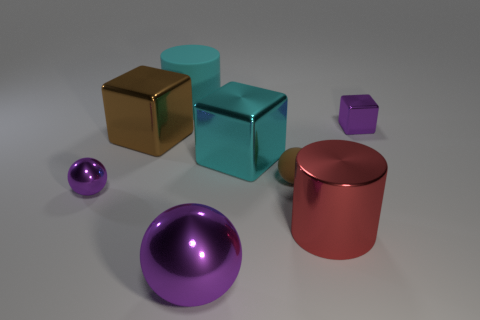Subtract all big spheres. How many spheres are left? 2 Subtract all blue cubes. How many purple spheres are left? 2 Add 2 large yellow matte things. How many objects exist? 10 Subtract 2 balls. How many balls are left? 1 Subtract all purple blocks. How many blocks are left? 2 Subtract all cubes. How many objects are left? 5 Subtract all cyan cylinders. Subtract all green cubes. How many cylinders are left? 1 Subtract all big green metal spheres. Subtract all large cubes. How many objects are left? 6 Add 4 tiny shiny objects. How many tiny shiny objects are left? 6 Add 6 tiny green rubber spheres. How many tiny green rubber spheres exist? 6 